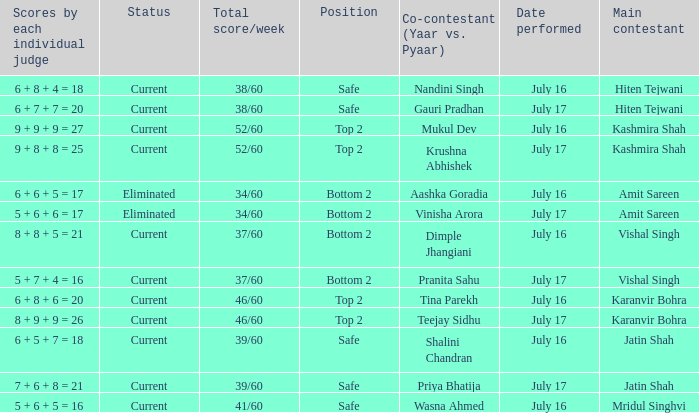What position did the team with the total score of 41/60 get? Safe. 